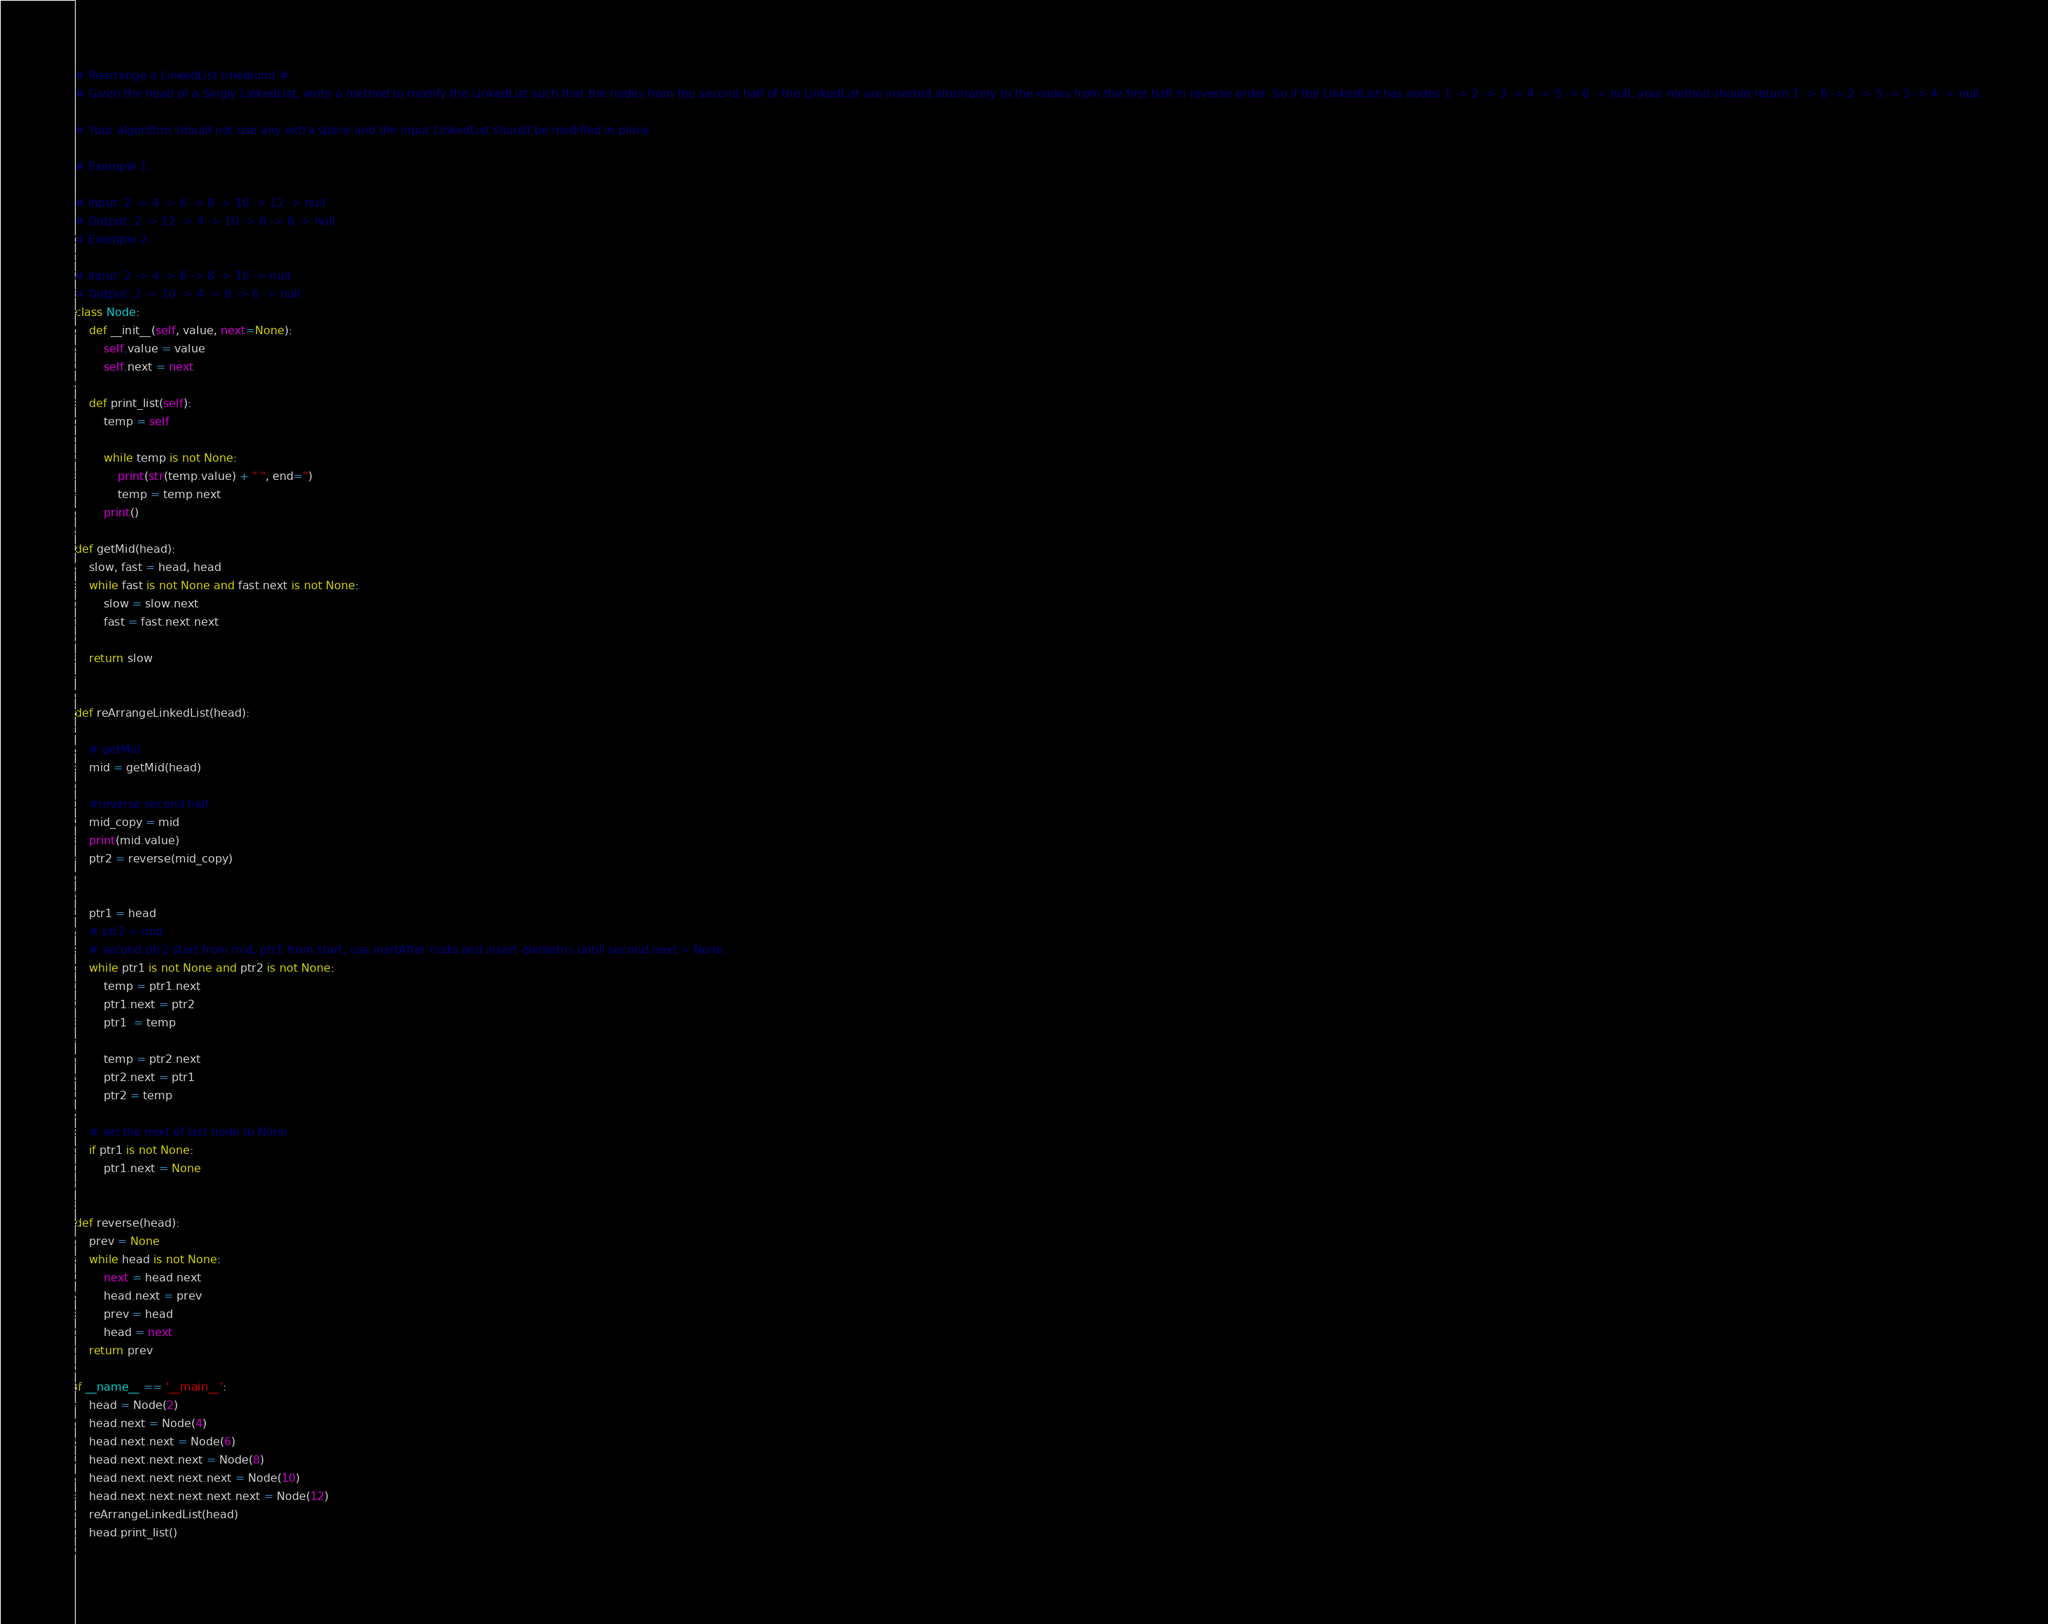<code> <loc_0><loc_0><loc_500><loc_500><_Python_># Rearrange a LinkedList (medium) #
# Given the head of a Singly LinkedList, write a method to modify the LinkedList such that the nodes from the second half of the LinkedList are inserted alternately to the nodes from the first half in reverse order. So if the LinkedList has nodes 1 -> 2 -> 3 -> 4 -> 5 -> 6 -> null, your method should return 1 -> 6 -> 2 -> 5 -> 3 -> 4 -> null.

# Your algorithm should not use any extra space and the input LinkedList should be modified in-place.

# Example 1:

# Input: 2 -> 4 -> 6 -> 8 -> 10 -> 12 -> null
# Output: 2 -> 12 -> 4 -> 10 -> 6 -> 8 -> null 
# Example 2:

# Input: 2 -> 4 -> 6 -> 8 -> 10 -> null
# Output: 2 -> 10 -> 4 -> 8 -> 6 -> null
class Node:
    def __init__(self, value, next=None):
        self.value = value
        self.next = next

    def print_list(self):
        temp = self

        while temp is not None:
            print(str(temp.value) + " ", end='')
            temp = temp.next
        print()

def getMid(head):
    slow, fast = head, head
    while fast is not None and fast.next is not None:
        slow = slow.next
        fast = fast.next.next
    
    return slow


def reArrangeLinkedList(head):

    # getMid
    mid = getMid(head)

    #reverse second half
    mid_copy = mid
    print(mid.value)
    ptr2 = reverse(mid_copy)

    
    ptr1 = head
    # ptr2 = mid
    # second ptr2 start from mid, ptr1 from start, use insrtAfter node and insert elemetns untill second.next = None.
    while ptr1 is not None and ptr2 is not None:
        temp = ptr1.next
        ptr1.next = ptr2
        ptr1  = temp

        temp = ptr2.next
        ptr2.next = ptr1
        ptr2 = temp

    # set the next of last node to None
    if ptr1 is not None:
        ptr1.next = None

        
def reverse(head):
    prev = None
    while head is not None:
        next = head.next
        head.next = prev
        prev = head
        head = next
    return prev

if __name__ == '__main__':
    head = Node(2)
    head.next = Node(4)
    head.next.next = Node(6)
    head.next.next.next = Node(8)
    head.next.next.next.next = Node(10)
    head.next.next.next.next.next = Node(12)
    reArrangeLinkedList(head)
    head.print_list()
    
</code> 